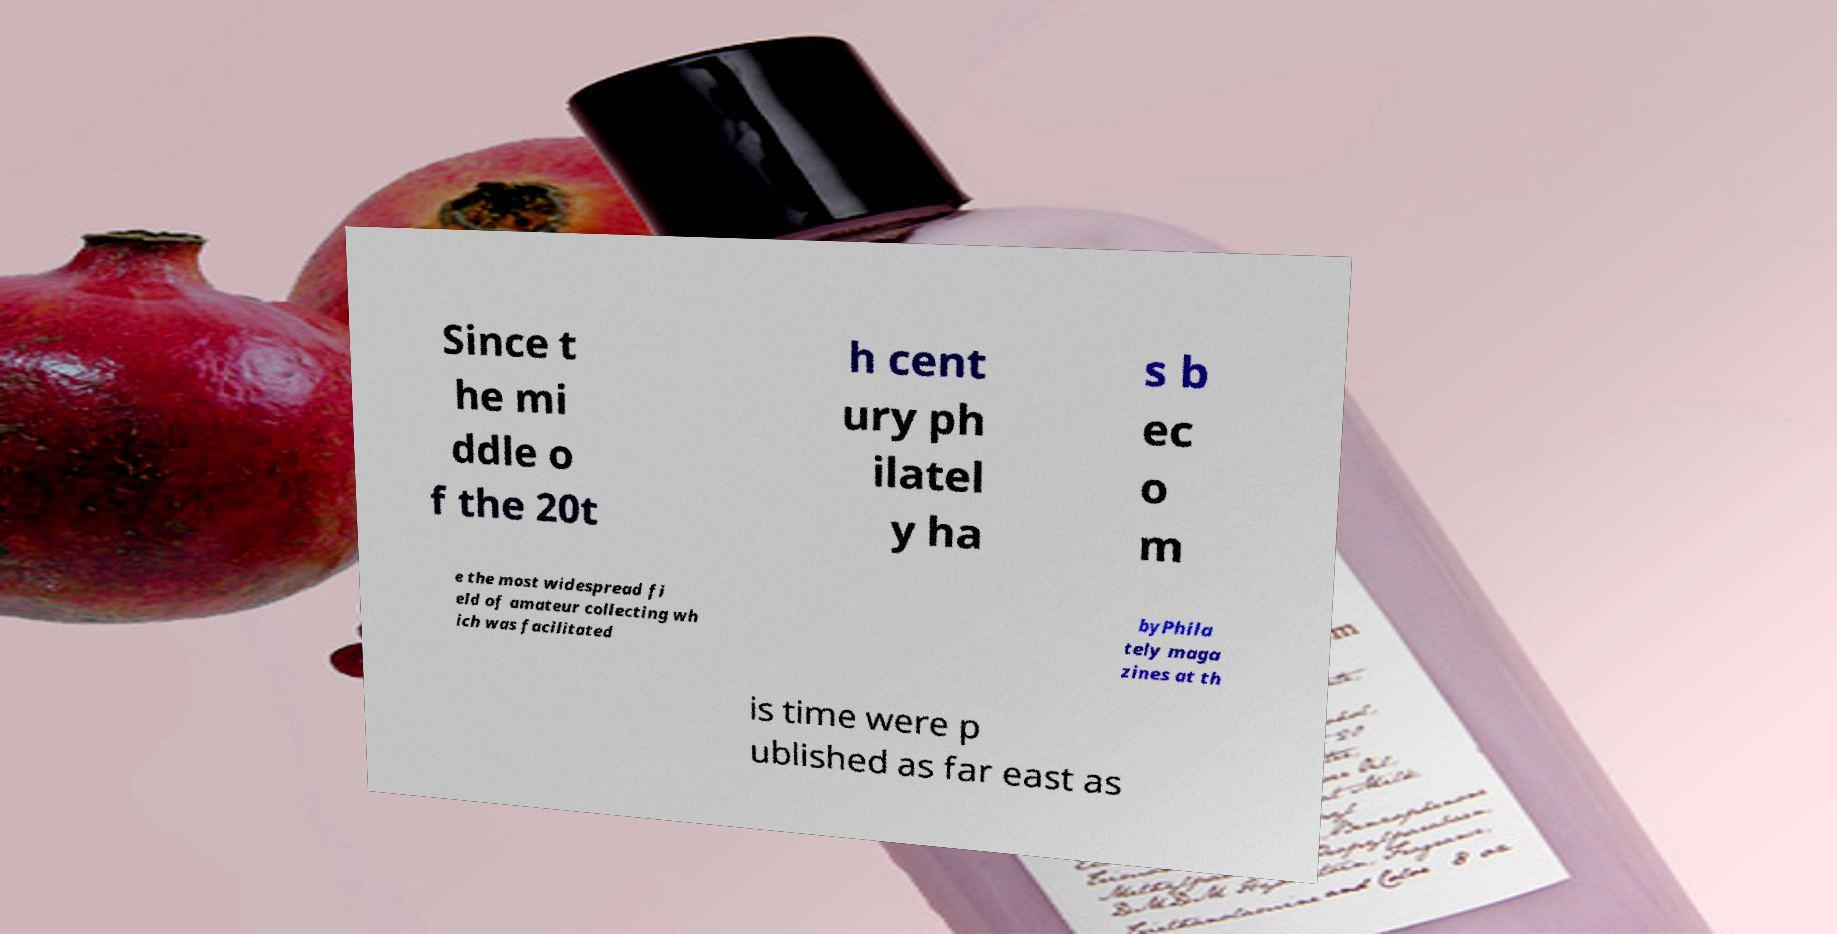Could you extract and type out the text from this image? Since t he mi ddle o f the 20t h cent ury ph ilatel y ha s b ec o m e the most widespread fi eld of amateur collecting wh ich was facilitated byPhila tely maga zines at th is time were p ublished as far east as 